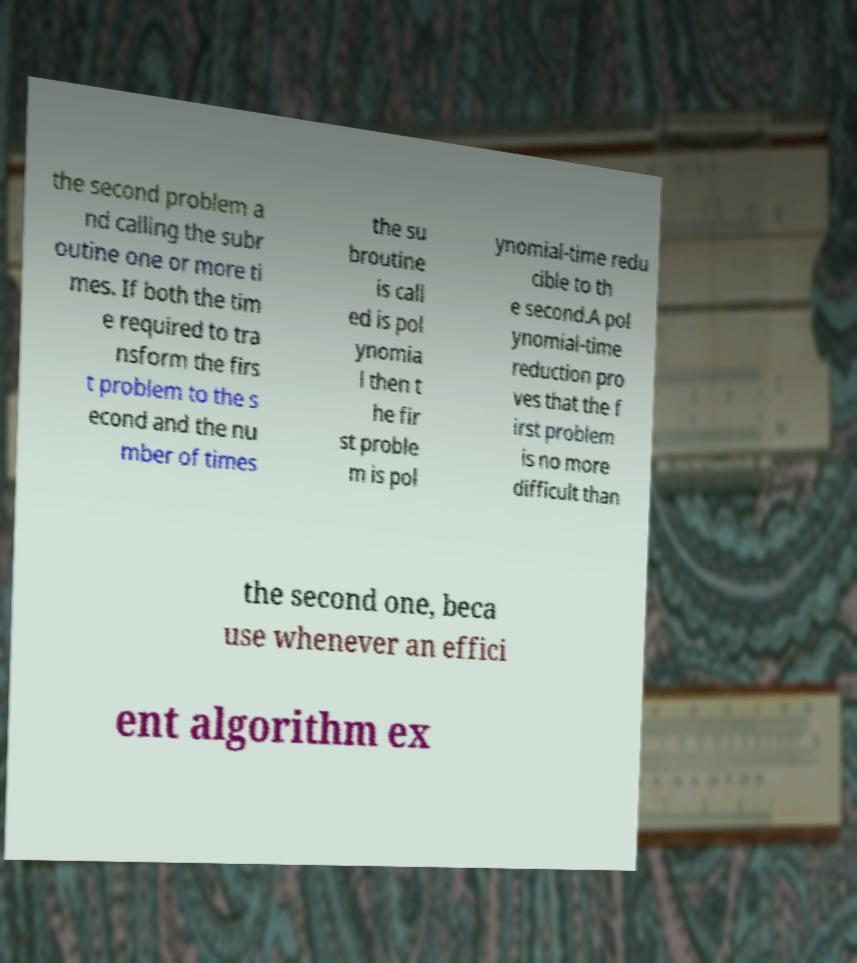Could you assist in decoding the text presented in this image and type it out clearly? the second problem a nd calling the subr outine one or more ti mes. If both the tim e required to tra nsform the firs t problem to the s econd and the nu mber of times the su broutine is call ed is pol ynomia l then t he fir st proble m is pol ynomial-time redu cible to th e second.A pol ynomial-time reduction pro ves that the f irst problem is no more difficult than the second one, beca use whenever an effici ent algorithm ex 